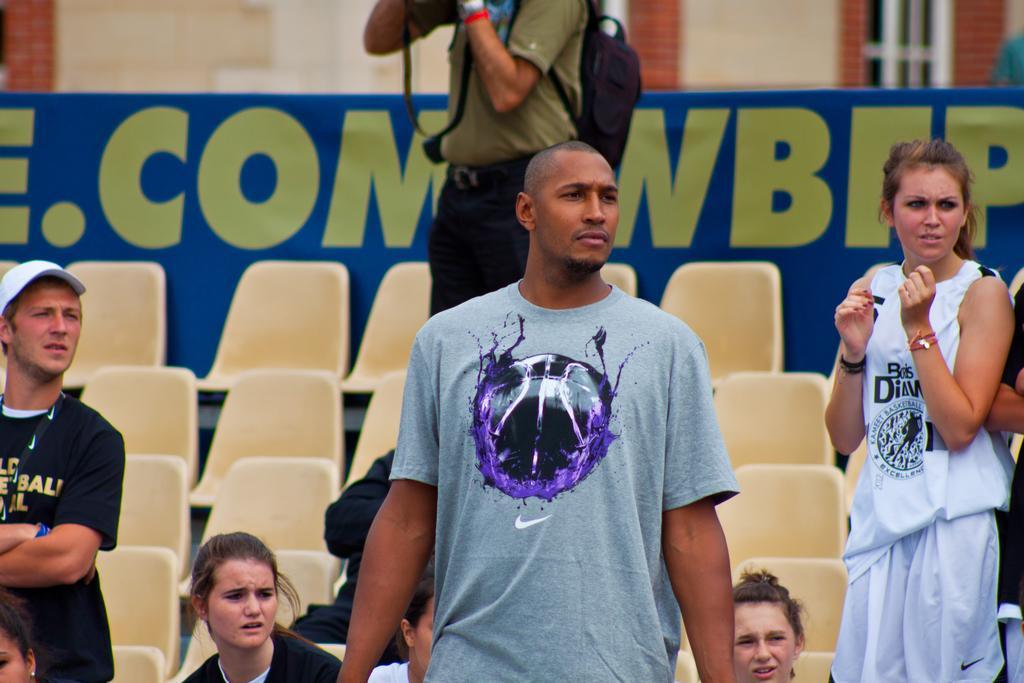Please provide a concise description of this image. This image consists of many people. In the background, there are chairs along with a banner. In the middle, there is a man standing on the chair and holding a camera. To the left, there is a man wearing a black T-shirt. 